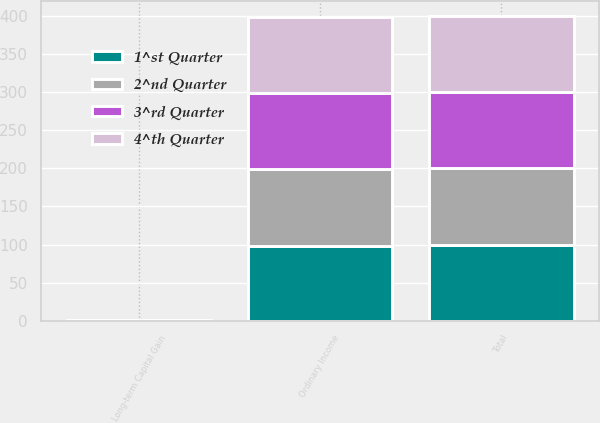<chart> <loc_0><loc_0><loc_500><loc_500><stacked_bar_chart><ecel><fcel>Ordinary Income<fcel>Long-term Capital Gain<fcel>Total<nl><fcel>4^th Quarter<fcel>100<fcel>0<fcel>100<nl><fcel>3^rd Quarter<fcel>100<fcel>0<fcel>100<nl><fcel>1^st Quarter<fcel>98.57<fcel>1.43<fcel>100<nl><fcel>2^nd Quarter<fcel>100<fcel>0<fcel>100<nl></chart> 